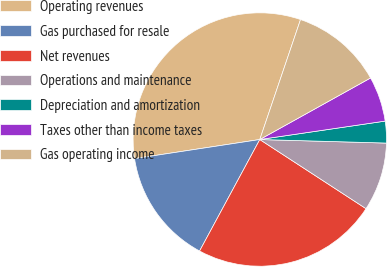<chart> <loc_0><loc_0><loc_500><loc_500><pie_chart><fcel>Operating revenues<fcel>Gas purchased for resale<fcel>Net revenues<fcel>Operations and maintenance<fcel>Depreciation and amortization<fcel>Taxes other than income taxes<fcel>Gas operating income<nl><fcel>32.62%<fcel>14.71%<fcel>23.7%<fcel>8.74%<fcel>2.77%<fcel>5.75%<fcel>11.72%<nl></chart> 